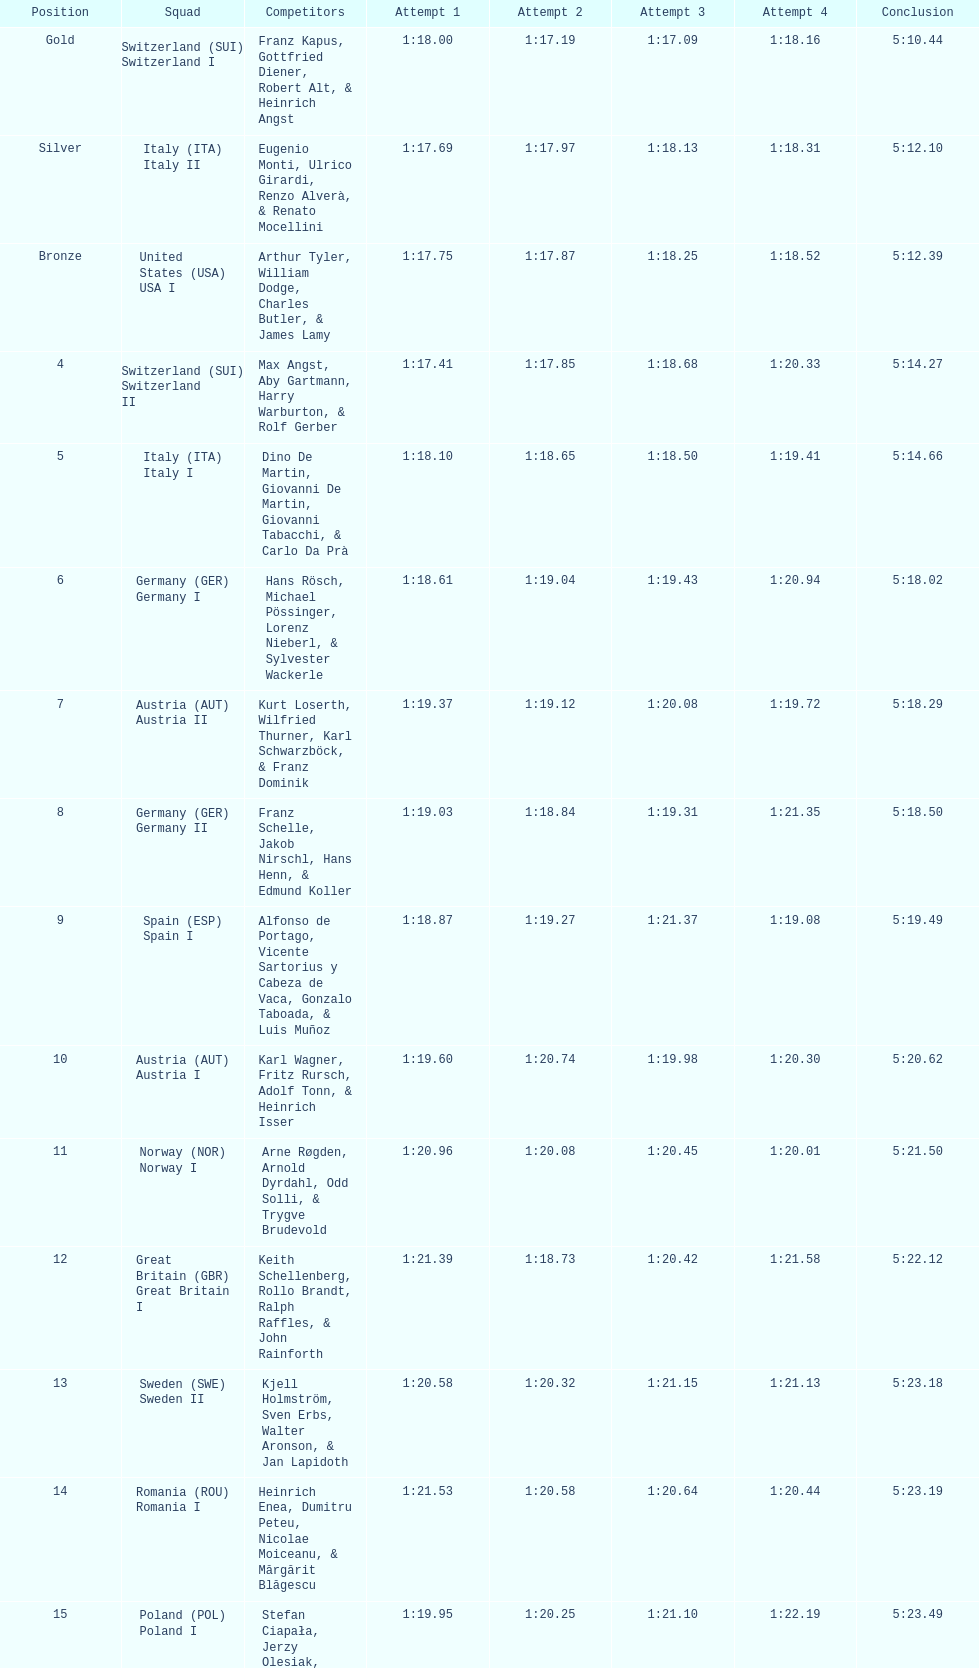Name a country that had 4 consecutive runs under 1:19. Switzerland. Parse the table in full. {'header': ['Position', 'Squad', 'Competitors', 'Attempt 1', 'Attempt 2', 'Attempt 3', 'Attempt 4', 'Conclusion'], 'rows': [['Gold', 'Switzerland\xa0(SUI) Switzerland I', 'Franz Kapus, Gottfried Diener, Robert Alt, & Heinrich Angst', '1:18.00', '1:17.19', '1:17.09', '1:18.16', '5:10.44'], ['Silver', 'Italy\xa0(ITA) Italy II', 'Eugenio Monti, Ulrico Girardi, Renzo Alverà, & Renato Mocellini', '1:17.69', '1:17.97', '1:18.13', '1:18.31', '5:12.10'], ['Bronze', 'United States\xa0(USA) USA I', 'Arthur Tyler, William Dodge, Charles Butler, & James Lamy', '1:17.75', '1:17.87', '1:18.25', '1:18.52', '5:12.39'], ['4', 'Switzerland\xa0(SUI) Switzerland II', 'Max Angst, Aby Gartmann, Harry Warburton, & Rolf Gerber', '1:17.41', '1:17.85', '1:18.68', '1:20.33', '5:14.27'], ['5', 'Italy\xa0(ITA) Italy I', 'Dino De Martin, Giovanni De Martin, Giovanni Tabacchi, & Carlo Da Prà', '1:18.10', '1:18.65', '1:18.50', '1:19.41', '5:14.66'], ['6', 'Germany\xa0(GER) Germany I', 'Hans Rösch, Michael Pössinger, Lorenz Nieberl, & Sylvester Wackerle', '1:18.61', '1:19.04', '1:19.43', '1:20.94', '5:18.02'], ['7', 'Austria\xa0(AUT) Austria II', 'Kurt Loserth, Wilfried Thurner, Karl Schwarzböck, & Franz Dominik', '1:19.37', '1:19.12', '1:20.08', '1:19.72', '5:18.29'], ['8', 'Germany\xa0(GER) Germany II', 'Franz Schelle, Jakob Nirschl, Hans Henn, & Edmund Koller', '1:19.03', '1:18.84', '1:19.31', '1:21.35', '5:18.50'], ['9', 'Spain\xa0(ESP) Spain I', 'Alfonso de Portago, Vicente Sartorius y Cabeza de Vaca, Gonzalo Taboada, & Luis Muñoz', '1:18.87', '1:19.27', '1:21.37', '1:19.08', '5:19.49'], ['10', 'Austria\xa0(AUT) Austria I', 'Karl Wagner, Fritz Rursch, Adolf Tonn, & Heinrich Isser', '1:19.60', '1:20.74', '1:19.98', '1:20.30', '5:20.62'], ['11', 'Norway\xa0(NOR) Norway I', 'Arne Røgden, Arnold Dyrdahl, Odd Solli, & Trygve Brudevold', '1:20.96', '1:20.08', '1:20.45', '1:20.01', '5:21.50'], ['12', 'Great Britain\xa0(GBR) Great Britain I', 'Keith Schellenberg, Rollo Brandt, Ralph Raffles, & John Rainforth', '1:21.39', '1:18.73', '1:20.42', '1:21.58', '5:22.12'], ['13', 'Sweden\xa0(SWE) Sweden II', 'Kjell Holmström, Sven Erbs, Walter Aronson, & Jan Lapidoth', '1:20.58', '1:20.32', '1:21.15', '1:21.13', '5:23.18'], ['14', 'Romania\xa0(ROU) Romania I', 'Heinrich Enea, Dumitru Peteu, Nicolae Moiceanu, & Mărgărit Blăgescu', '1:21.53', '1:20.58', '1:20.64', '1:20.44', '5:23.19'], ['15', 'Poland\xa0(POL) Poland I', 'Stefan Ciapała, Jerzy Olesiak, Józef Szymański, & Aleksander Habala', '1:19.95', '1:20.25', '1:21.10', '1:22.19', '5:23.49'], ['16', 'Sweden\xa0(SWE) Sweden I', 'Olle Axelsson, Ebbe Wallén, Sune Skagerling, & Gunnar Åhs', '1:18.95', '1:19.98', '1:22.75', '1:21.86', '5:23.54'], ['17', 'Great Britain\xa0(GBR) Great Britain II', 'Stuart Parkinson, John Read, Christopher Williams, & Rodney Mann', '1:20.72', '1:19.92', '1:22.51', '1:20.58', '5:23.73'], ['18', 'France\xa0(FRA) France I', 'André Robin, Pierre Bouvier, Jacques Panciroli, & Lucien Grosso', '1:20.00', '1:21.25', '1:20.95', '1:21.63', '5:23.83'], ['19', 'United States\xa0(USA) USA II', 'James Bickford, Donald Jacques, Lawrence McKillip, & Hubert Miller', '1:20.97', '1:22.47', '1:21.22', '1:20.50', '5:25.16'], ['20', 'Romania\xa0(ROU) Romania II', 'Constantin Dragomir, Vasile Panait, Ion Staicu, & Gheorghe Moldoveanu', '1:21.21', '1:21.22', '1:22.37', '1:23.03', '5:27.83'], ['21', 'Poland\xa0(POL) Poland II', 'Aleksy Konieczny, Zygmunt Konieczny, Włodzimierz Źróbik, & Zbigniew Skowroński/Jan Dąbrowski(*)', '', '', '', '', '5:28.40']]} 